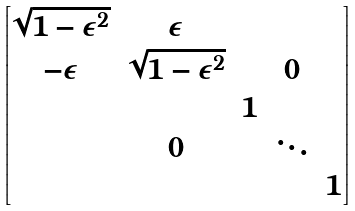<formula> <loc_0><loc_0><loc_500><loc_500>\begin{bmatrix} \sqrt { 1 - \epsilon ^ { 2 } } & \epsilon & & & \\ - \epsilon & \sqrt { 1 - \epsilon ^ { 2 } } & & 0 & \\ & & 1 & & \\ & 0 & & \ddots & \\ & & & & 1 \end{bmatrix}</formula> 